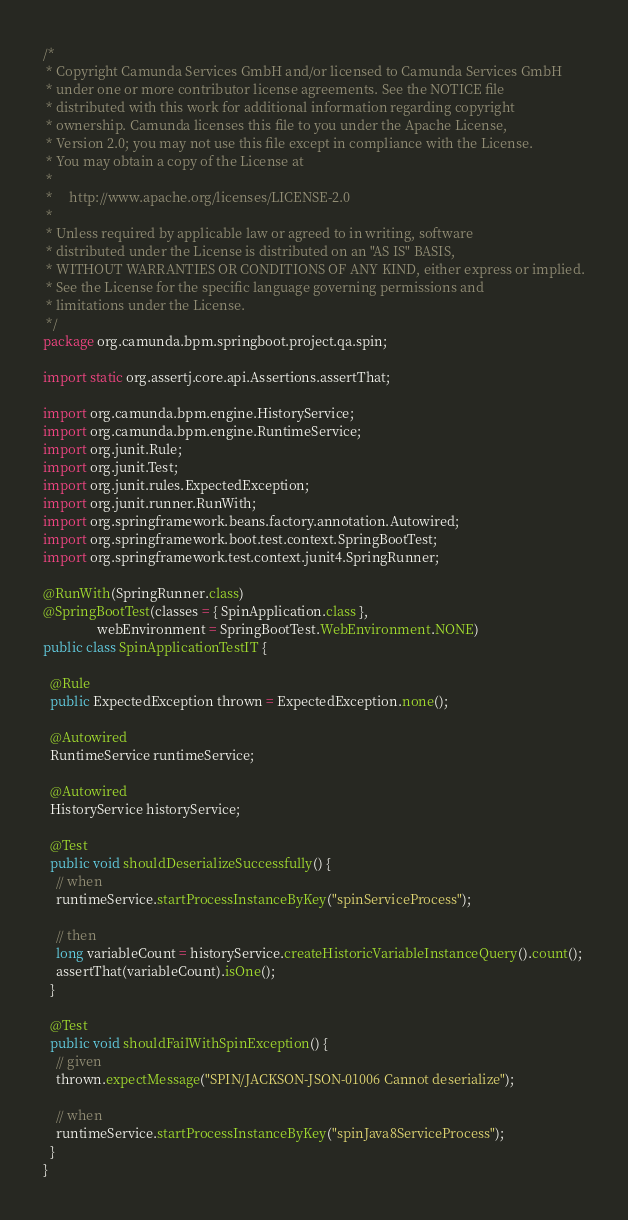Convert code to text. <code><loc_0><loc_0><loc_500><loc_500><_Java_>/*
 * Copyright Camunda Services GmbH and/or licensed to Camunda Services GmbH
 * under one or more contributor license agreements. See the NOTICE file
 * distributed with this work for additional information regarding copyright
 * ownership. Camunda licenses this file to you under the Apache License,
 * Version 2.0; you may not use this file except in compliance with the License.
 * You may obtain a copy of the License at
 *
 *     http://www.apache.org/licenses/LICENSE-2.0
 *
 * Unless required by applicable law or agreed to in writing, software
 * distributed under the License is distributed on an "AS IS" BASIS,
 * WITHOUT WARRANTIES OR CONDITIONS OF ANY KIND, either express or implied.
 * See the License for the specific language governing permissions and
 * limitations under the License.
 */
package org.camunda.bpm.springboot.project.qa.spin;

import static org.assertj.core.api.Assertions.assertThat;

import org.camunda.bpm.engine.HistoryService;
import org.camunda.bpm.engine.RuntimeService;
import org.junit.Rule;
import org.junit.Test;
import org.junit.rules.ExpectedException;
import org.junit.runner.RunWith;
import org.springframework.beans.factory.annotation.Autowired;
import org.springframework.boot.test.context.SpringBootTest;
import org.springframework.test.context.junit4.SpringRunner;

@RunWith(SpringRunner.class)
@SpringBootTest(classes = { SpinApplication.class },
                webEnvironment = SpringBootTest.WebEnvironment.NONE)
public class SpinApplicationTestIT {

  @Rule
  public ExpectedException thrown = ExpectedException.none();

  @Autowired
  RuntimeService runtimeService;

  @Autowired
  HistoryService historyService;

  @Test
  public void shouldDeserializeSuccessfully() {
    // when
    runtimeService.startProcessInstanceByKey("spinServiceProcess");

    // then
    long variableCount = historyService.createHistoricVariableInstanceQuery().count();
    assertThat(variableCount).isOne();
  }

  @Test
  public void shouldFailWithSpinException() {
    // given
    thrown.expectMessage("SPIN/JACKSON-JSON-01006 Cannot deserialize");

    // when
    runtimeService.startProcessInstanceByKey("spinJava8ServiceProcess");
  }
}
</code> 